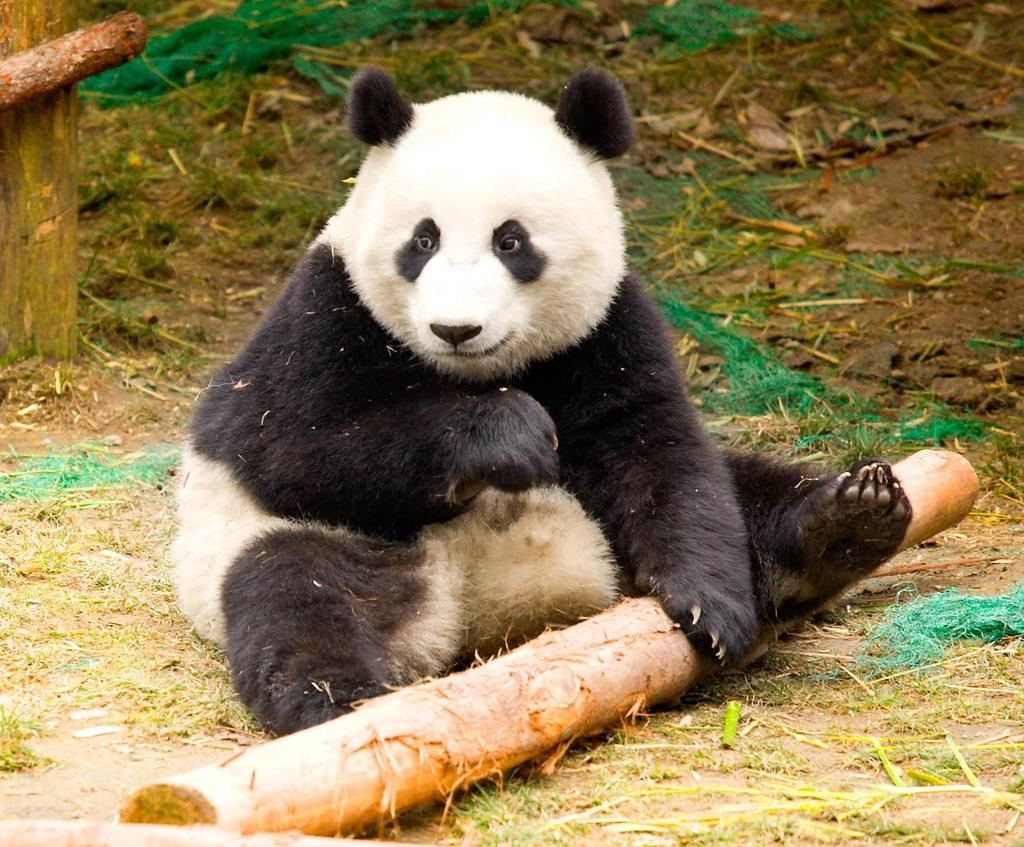What animal is present in the image? There is a panda in the image. What is the panda doing in the image? The panda is sitting. What type of objects can be seen in the image? There are wooden objects in the image. What type of natural environment is visible in the image? There is grass visible in the image. How does the crowd react to the panda in the image? There is no crowd present in the image, so it is not possible to determine how they might react to the panda. 